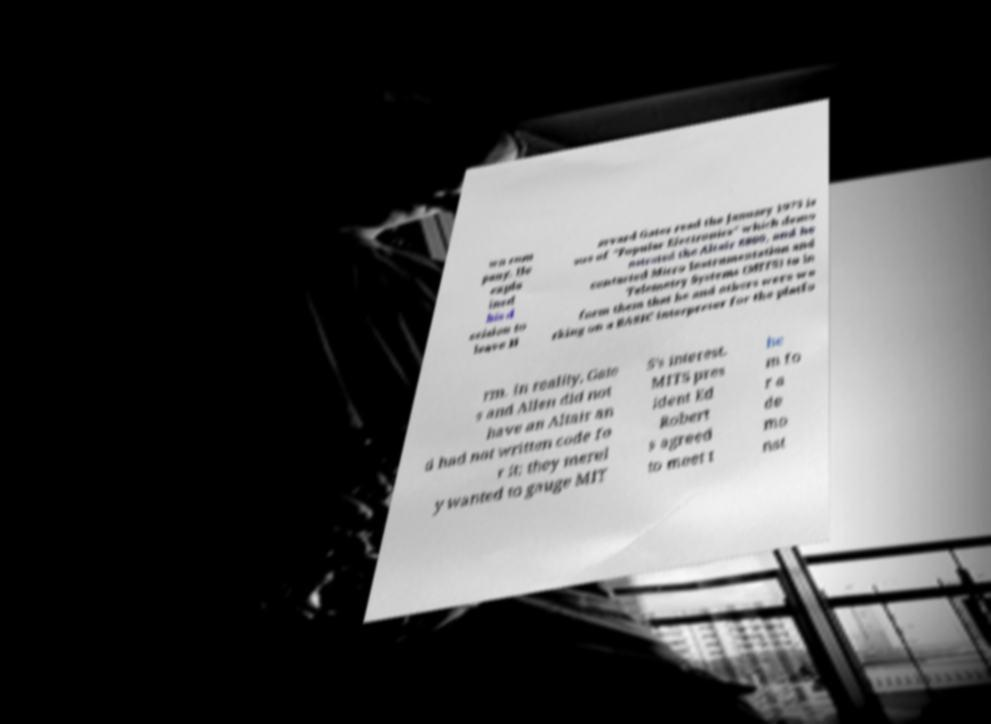Please identify and transcribe the text found in this image. wn com pany. He expla ined his d ecision to leave H arvard Gates read the January 1975 is sue of "Popular Electronics" which demo nstrated the Altair 8800, and he contacted Micro Instrumentation and Telemetry Systems (MITS) to in form them that he and others were wo rking on a BASIC interpreter for the platfo rm. In reality, Gate s and Allen did not have an Altair an d had not written code fo r it; they merel y wanted to gauge MIT S's interest. MITS pres ident Ed Robert s agreed to meet t he m fo r a de mo nst 